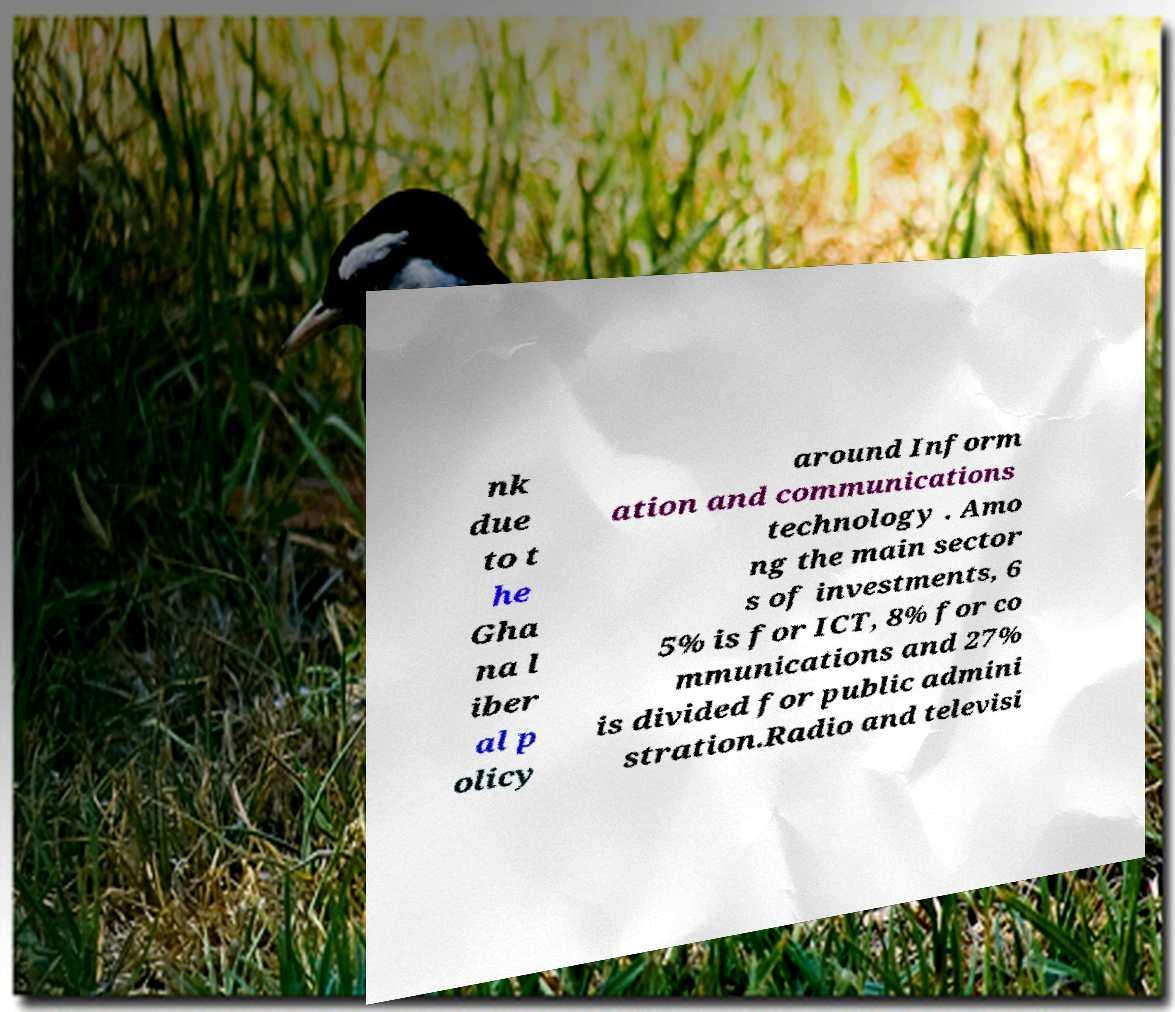What messages or text are displayed in this image? I need them in a readable, typed format. nk due to t he Gha na l iber al p olicy around Inform ation and communications technology . Amo ng the main sector s of investments, 6 5% is for ICT, 8% for co mmunications and 27% is divided for public admini stration.Radio and televisi 